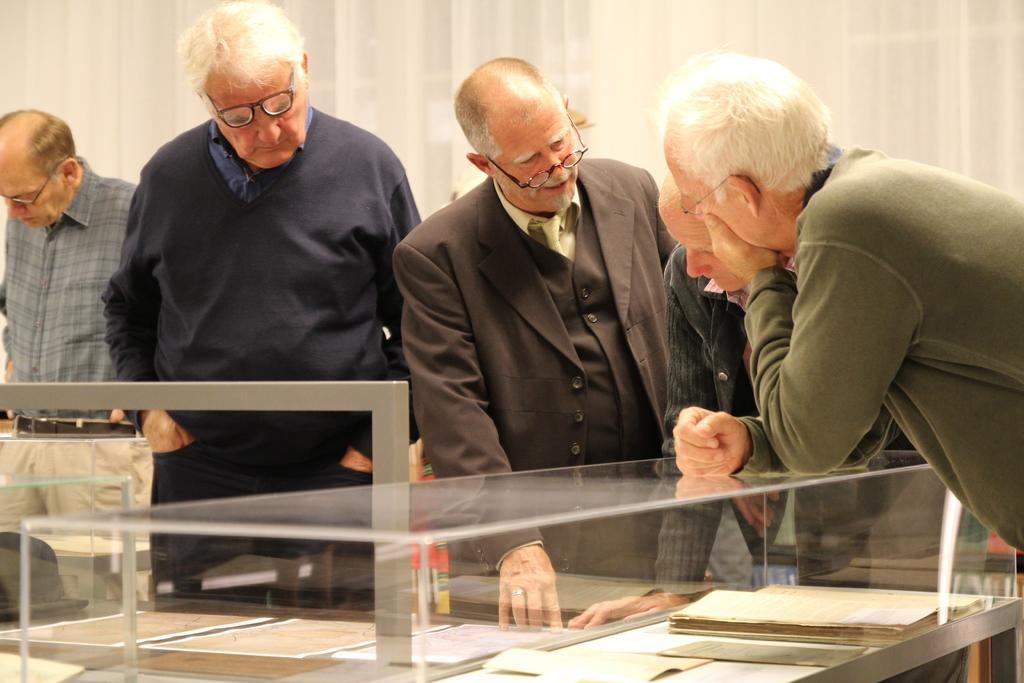Who or what can be seen in the image? There are people in the image. What is the main object in the image? There is a table in the image. What items are on the table? Papers and a book are present on the table. What type of container is visible in the image? There is a glass in the image. What other object can be seen in the image? There is a rod in the image. What is the color of the background in the image? The background of the image is white. How many fingers can be seen on the person's hand in the image? There is no visible hand or fingers in the image. What type of steel object is present in the image? There is no steel object present in the image. 